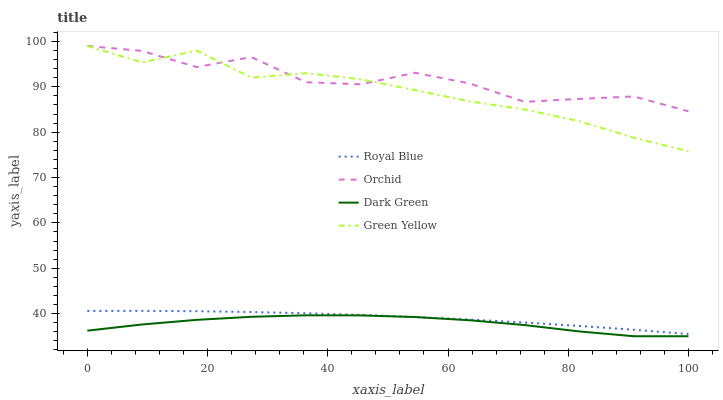Does Dark Green have the minimum area under the curve?
Answer yes or no. Yes. Does Orchid have the maximum area under the curve?
Answer yes or no. Yes. Does Green Yellow have the minimum area under the curve?
Answer yes or no. No. Does Green Yellow have the maximum area under the curve?
Answer yes or no. No. Is Royal Blue the smoothest?
Answer yes or no. Yes. Is Orchid the roughest?
Answer yes or no. Yes. Is Green Yellow the smoothest?
Answer yes or no. No. Is Green Yellow the roughest?
Answer yes or no. No. Does Dark Green have the lowest value?
Answer yes or no. Yes. Does Green Yellow have the lowest value?
Answer yes or no. No. Does Orchid have the highest value?
Answer yes or no. Yes. Does Dark Green have the highest value?
Answer yes or no. No. Is Royal Blue less than Green Yellow?
Answer yes or no. Yes. Is Orchid greater than Royal Blue?
Answer yes or no. Yes. Does Orchid intersect Green Yellow?
Answer yes or no. Yes. Is Orchid less than Green Yellow?
Answer yes or no. No. Is Orchid greater than Green Yellow?
Answer yes or no. No. Does Royal Blue intersect Green Yellow?
Answer yes or no. No. 